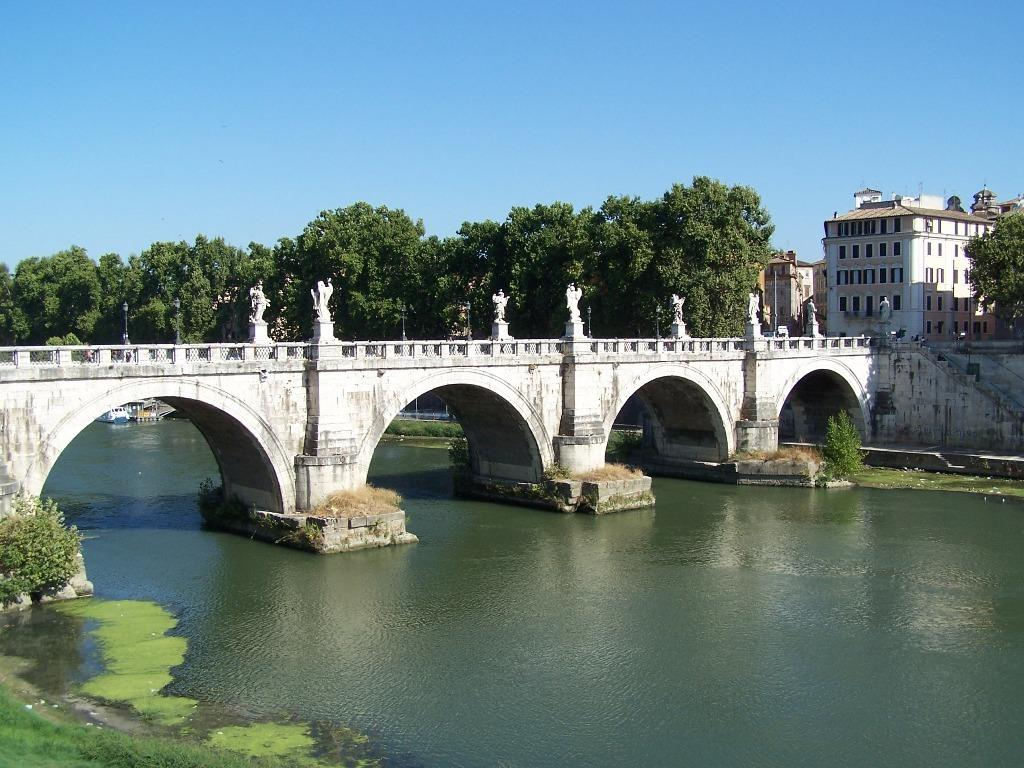What type of structure can be seen in the image? There is a bridge in the image. What architectural feature is present near the bridge? There are stairs in the image. What natural element is visible in the image? There is water visible in the image, with a layer on top of it. What type of vegetation is present in the image? There are plants and trees in the image. What type of ground surface is visible in the image? The ground with grass is present in the image. What type of buildings can be seen in the image? There are buildings with windows in the image. What part of the natural environment is visible in the image? The sky is visible in the image. Can you tell me how many hens are present on the bridge in the image? There are no hens present in the image; it features a bridge, stairs, water, plants, trees, grass, buildings, and the sky. What is the hen's wish while standing on the bridge in the image? There is no hen present in the image, so it is not possible to determine its wish. 